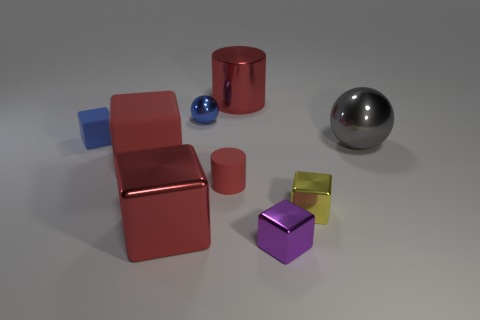Subtract all yellow blocks. How many blocks are left? 4 Subtract all tiny purple shiny blocks. How many blocks are left? 4 Subtract all cyan blocks. Subtract all red spheres. How many blocks are left? 5 Add 1 large yellow shiny cylinders. How many objects exist? 10 Subtract all cylinders. How many objects are left? 7 Subtract all tiny red cylinders. Subtract all shiny cylinders. How many objects are left? 7 Add 7 small blue rubber blocks. How many small blue rubber blocks are left? 8 Add 5 red blocks. How many red blocks exist? 7 Subtract 0 purple balls. How many objects are left? 9 